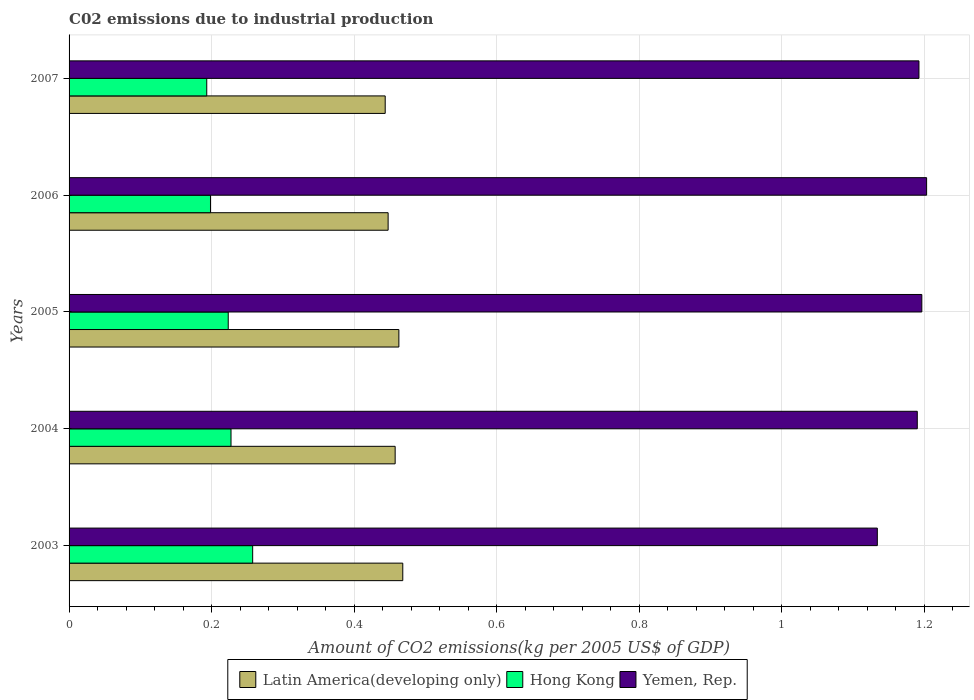How many groups of bars are there?
Provide a succinct answer. 5. Are the number of bars per tick equal to the number of legend labels?
Offer a terse response. Yes. What is the label of the 2nd group of bars from the top?
Give a very brief answer. 2006. What is the amount of CO2 emitted due to industrial production in Yemen, Rep. in 2003?
Make the answer very short. 1.13. Across all years, what is the maximum amount of CO2 emitted due to industrial production in Hong Kong?
Provide a succinct answer. 0.26. Across all years, what is the minimum amount of CO2 emitted due to industrial production in Yemen, Rep.?
Give a very brief answer. 1.13. In which year was the amount of CO2 emitted due to industrial production in Hong Kong minimum?
Provide a succinct answer. 2007. What is the total amount of CO2 emitted due to industrial production in Yemen, Rep. in the graph?
Keep it short and to the point. 5.92. What is the difference between the amount of CO2 emitted due to industrial production in Hong Kong in 2005 and that in 2006?
Provide a succinct answer. 0.02. What is the difference between the amount of CO2 emitted due to industrial production in Yemen, Rep. in 2007 and the amount of CO2 emitted due to industrial production in Latin America(developing only) in 2003?
Your answer should be compact. 0.72. What is the average amount of CO2 emitted due to industrial production in Latin America(developing only) per year?
Provide a short and direct response. 0.46. In the year 2005, what is the difference between the amount of CO2 emitted due to industrial production in Latin America(developing only) and amount of CO2 emitted due to industrial production in Yemen, Rep.?
Make the answer very short. -0.73. What is the ratio of the amount of CO2 emitted due to industrial production in Latin America(developing only) in 2004 to that in 2005?
Offer a very short reply. 0.99. Is the amount of CO2 emitted due to industrial production in Hong Kong in 2005 less than that in 2007?
Your response must be concise. No. What is the difference between the highest and the second highest amount of CO2 emitted due to industrial production in Yemen, Rep.?
Your answer should be compact. 0.01. What is the difference between the highest and the lowest amount of CO2 emitted due to industrial production in Latin America(developing only)?
Ensure brevity in your answer.  0.02. In how many years, is the amount of CO2 emitted due to industrial production in Hong Kong greater than the average amount of CO2 emitted due to industrial production in Hong Kong taken over all years?
Your response must be concise. 3. Is the sum of the amount of CO2 emitted due to industrial production in Hong Kong in 2005 and 2006 greater than the maximum amount of CO2 emitted due to industrial production in Latin America(developing only) across all years?
Offer a terse response. No. What does the 1st bar from the top in 2006 represents?
Your answer should be very brief. Yemen, Rep. What does the 1st bar from the bottom in 2003 represents?
Ensure brevity in your answer.  Latin America(developing only). Is it the case that in every year, the sum of the amount of CO2 emitted due to industrial production in Latin America(developing only) and amount of CO2 emitted due to industrial production in Yemen, Rep. is greater than the amount of CO2 emitted due to industrial production in Hong Kong?
Make the answer very short. Yes. Are all the bars in the graph horizontal?
Provide a succinct answer. Yes. What is the difference between two consecutive major ticks on the X-axis?
Offer a terse response. 0.2. Are the values on the major ticks of X-axis written in scientific E-notation?
Keep it short and to the point. No. Does the graph contain any zero values?
Ensure brevity in your answer.  No. Does the graph contain grids?
Your response must be concise. Yes. What is the title of the graph?
Keep it short and to the point. C02 emissions due to industrial production. Does "Sweden" appear as one of the legend labels in the graph?
Offer a very short reply. No. What is the label or title of the X-axis?
Offer a terse response. Amount of CO2 emissions(kg per 2005 US$ of GDP). What is the label or title of the Y-axis?
Ensure brevity in your answer.  Years. What is the Amount of CO2 emissions(kg per 2005 US$ of GDP) in Latin America(developing only) in 2003?
Give a very brief answer. 0.47. What is the Amount of CO2 emissions(kg per 2005 US$ of GDP) in Hong Kong in 2003?
Make the answer very short. 0.26. What is the Amount of CO2 emissions(kg per 2005 US$ of GDP) of Yemen, Rep. in 2003?
Provide a short and direct response. 1.13. What is the Amount of CO2 emissions(kg per 2005 US$ of GDP) in Latin America(developing only) in 2004?
Offer a terse response. 0.46. What is the Amount of CO2 emissions(kg per 2005 US$ of GDP) in Hong Kong in 2004?
Make the answer very short. 0.23. What is the Amount of CO2 emissions(kg per 2005 US$ of GDP) in Yemen, Rep. in 2004?
Provide a short and direct response. 1.19. What is the Amount of CO2 emissions(kg per 2005 US$ of GDP) of Latin America(developing only) in 2005?
Ensure brevity in your answer.  0.46. What is the Amount of CO2 emissions(kg per 2005 US$ of GDP) in Hong Kong in 2005?
Keep it short and to the point. 0.22. What is the Amount of CO2 emissions(kg per 2005 US$ of GDP) of Yemen, Rep. in 2005?
Give a very brief answer. 1.2. What is the Amount of CO2 emissions(kg per 2005 US$ of GDP) of Latin America(developing only) in 2006?
Your response must be concise. 0.45. What is the Amount of CO2 emissions(kg per 2005 US$ of GDP) of Hong Kong in 2006?
Make the answer very short. 0.2. What is the Amount of CO2 emissions(kg per 2005 US$ of GDP) of Yemen, Rep. in 2006?
Give a very brief answer. 1.2. What is the Amount of CO2 emissions(kg per 2005 US$ of GDP) of Latin America(developing only) in 2007?
Your answer should be very brief. 0.44. What is the Amount of CO2 emissions(kg per 2005 US$ of GDP) of Hong Kong in 2007?
Give a very brief answer. 0.19. What is the Amount of CO2 emissions(kg per 2005 US$ of GDP) of Yemen, Rep. in 2007?
Ensure brevity in your answer.  1.19. Across all years, what is the maximum Amount of CO2 emissions(kg per 2005 US$ of GDP) in Latin America(developing only)?
Provide a short and direct response. 0.47. Across all years, what is the maximum Amount of CO2 emissions(kg per 2005 US$ of GDP) of Hong Kong?
Provide a succinct answer. 0.26. Across all years, what is the maximum Amount of CO2 emissions(kg per 2005 US$ of GDP) in Yemen, Rep.?
Provide a succinct answer. 1.2. Across all years, what is the minimum Amount of CO2 emissions(kg per 2005 US$ of GDP) in Latin America(developing only)?
Offer a terse response. 0.44. Across all years, what is the minimum Amount of CO2 emissions(kg per 2005 US$ of GDP) in Hong Kong?
Provide a short and direct response. 0.19. Across all years, what is the minimum Amount of CO2 emissions(kg per 2005 US$ of GDP) of Yemen, Rep.?
Provide a short and direct response. 1.13. What is the total Amount of CO2 emissions(kg per 2005 US$ of GDP) of Latin America(developing only) in the graph?
Ensure brevity in your answer.  2.28. What is the total Amount of CO2 emissions(kg per 2005 US$ of GDP) in Hong Kong in the graph?
Ensure brevity in your answer.  1.1. What is the total Amount of CO2 emissions(kg per 2005 US$ of GDP) of Yemen, Rep. in the graph?
Provide a short and direct response. 5.92. What is the difference between the Amount of CO2 emissions(kg per 2005 US$ of GDP) of Latin America(developing only) in 2003 and that in 2004?
Provide a succinct answer. 0.01. What is the difference between the Amount of CO2 emissions(kg per 2005 US$ of GDP) in Hong Kong in 2003 and that in 2004?
Give a very brief answer. 0.03. What is the difference between the Amount of CO2 emissions(kg per 2005 US$ of GDP) in Yemen, Rep. in 2003 and that in 2004?
Provide a succinct answer. -0.06. What is the difference between the Amount of CO2 emissions(kg per 2005 US$ of GDP) of Latin America(developing only) in 2003 and that in 2005?
Give a very brief answer. 0.01. What is the difference between the Amount of CO2 emissions(kg per 2005 US$ of GDP) in Hong Kong in 2003 and that in 2005?
Your answer should be very brief. 0.03. What is the difference between the Amount of CO2 emissions(kg per 2005 US$ of GDP) of Yemen, Rep. in 2003 and that in 2005?
Your response must be concise. -0.06. What is the difference between the Amount of CO2 emissions(kg per 2005 US$ of GDP) of Latin America(developing only) in 2003 and that in 2006?
Give a very brief answer. 0.02. What is the difference between the Amount of CO2 emissions(kg per 2005 US$ of GDP) in Hong Kong in 2003 and that in 2006?
Offer a very short reply. 0.06. What is the difference between the Amount of CO2 emissions(kg per 2005 US$ of GDP) in Yemen, Rep. in 2003 and that in 2006?
Give a very brief answer. -0.07. What is the difference between the Amount of CO2 emissions(kg per 2005 US$ of GDP) in Latin America(developing only) in 2003 and that in 2007?
Your answer should be very brief. 0.02. What is the difference between the Amount of CO2 emissions(kg per 2005 US$ of GDP) in Hong Kong in 2003 and that in 2007?
Offer a very short reply. 0.06. What is the difference between the Amount of CO2 emissions(kg per 2005 US$ of GDP) of Yemen, Rep. in 2003 and that in 2007?
Ensure brevity in your answer.  -0.06. What is the difference between the Amount of CO2 emissions(kg per 2005 US$ of GDP) of Latin America(developing only) in 2004 and that in 2005?
Keep it short and to the point. -0.01. What is the difference between the Amount of CO2 emissions(kg per 2005 US$ of GDP) in Hong Kong in 2004 and that in 2005?
Your response must be concise. 0. What is the difference between the Amount of CO2 emissions(kg per 2005 US$ of GDP) of Yemen, Rep. in 2004 and that in 2005?
Provide a short and direct response. -0.01. What is the difference between the Amount of CO2 emissions(kg per 2005 US$ of GDP) in Latin America(developing only) in 2004 and that in 2006?
Provide a succinct answer. 0.01. What is the difference between the Amount of CO2 emissions(kg per 2005 US$ of GDP) in Hong Kong in 2004 and that in 2006?
Offer a terse response. 0.03. What is the difference between the Amount of CO2 emissions(kg per 2005 US$ of GDP) of Yemen, Rep. in 2004 and that in 2006?
Your response must be concise. -0.01. What is the difference between the Amount of CO2 emissions(kg per 2005 US$ of GDP) in Latin America(developing only) in 2004 and that in 2007?
Ensure brevity in your answer.  0.01. What is the difference between the Amount of CO2 emissions(kg per 2005 US$ of GDP) of Hong Kong in 2004 and that in 2007?
Provide a short and direct response. 0.03. What is the difference between the Amount of CO2 emissions(kg per 2005 US$ of GDP) in Yemen, Rep. in 2004 and that in 2007?
Keep it short and to the point. -0. What is the difference between the Amount of CO2 emissions(kg per 2005 US$ of GDP) of Latin America(developing only) in 2005 and that in 2006?
Ensure brevity in your answer.  0.02. What is the difference between the Amount of CO2 emissions(kg per 2005 US$ of GDP) in Hong Kong in 2005 and that in 2006?
Provide a short and direct response. 0.02. What is the difference between the Amount of CO2 emissions(kg per 2005 US$ of GDP) of Yemen, Rep. in 2005 and that in 2006?
Offer a very short reply. -0.01. What is the difference between the Amount of CO2 emissions(kg per 2005 US$ of GDP) in Latin America(developing only) in 2005 and that in 2007?
Your answer should be very brief. 0.02. What is the difference between the Amount of CO2 emissions(kg per 2005 US$ of GDP) of Hong Kong in 2005 and that in 2007?
Your response must be concise. 0.03. What is the difference between the Amount of CO2 emissions(kg per 2005 US$ of GDP) of Yemen, Rep. in 2005 and that in 2007?
Keep it short and to the point. 0. What is the difference between the Amount of CO2 emissions(kg per 2005 US$ of GDP) of Latin America(developing only) in 2006 and that in 2007?
Keep it short and to the point. 0. What is the difference between the Amount of CO2 emissions(kg per 2005 US$ of GDP) of Hong Kong in 2006 and that in 2007?
Ensure brevity in your answer.  0.01. What is the difference between the Amount of CO2 emissions(kg per 2005 US$ of GDP) of Yemen, Rep. in 2006 and that in 2007?
Make the answer very short. 0.01. What is the difference between the Amount of CO2 emissions(kg per 2005 US$ of GDP) of Latin America(developing only) in 2003 and the Amount of CO2 emissions(kg per 2005 US$ of GDP) of Hong Kong in 2004?
Provide a succinct answer. 0.24. What is the difference between the Amount of CO2 emissions(kg per 2005 US$ of GDP) in Latin America(developing only) in 2003 and the Amount of CO2 emissions(kg per 2005 US$ of GDP) in Yemen, Rep. in 2004?
Your response must be concise. -0.72. What is the difference between the Amount of CO2 emissions(kg per 2005 US$ of GDP) in Hong Kong in 2003 and the Amount of CO2 emissions(kg per 2005 US$ of GDP) in Yemen, Rep. in 2004?
Offer a very short reply. -0.93. What is the difference between the Amount of CO2 emissions(kg per 2005 US$ of GDP) of Latin America(developing only) in 2003 and the Amount of CO2 emissions(kg per 2005 US$ of GDP) of Hong Kong in 2005?
Your response must be concise. 0.24. What is the difference between the Amount of CO2 emissions(kg per 2005 US$ of GDP) in Latin America(developing only) in 2003 and the Amount of CO2 emissions(kg per 2005 US$ of GDP) in Yemen, Rep. in 2005?
Keep it short and to the point. -0.73. What is the difference between the Amount of CO2 emissions(kg per 2005 US$ of GDP) of Hong Kong in 2003 and the Amount of CO2 emissions(kg per 2005 US$ of GDP) of Yemen, Rep. in 2005?
Ensure brevity in your answer.  -0.94. What is the difference between the Amount of CO2 emissions(kg per 2005 US$ of GDP) in Latin America(developing only) in 2003 and the Amount of CO2 emissions(kg per 2005 US$ of GDP) in Hong Kong in 2006?
Ensure brevity in your answer.  0.27. What is the difference between the Amount of CO2 emissions(kg per 2005 US$ of GDP) in Latin America(developing only) in 2003 and the Amount of CO2 emissions(kg per 2005 US$ of GDP) in Yemen, Rep. in 2006?
Your answer should be compact. -0.73. What is the difference between the Amount of CO2 emissions(kg per 2005 US$ of GDP) of Hong Kong in 2003 and the Amount of CO2 emissions(kg per 2005 US$ of GDP) of Yemen, Rep. in 2006?
Ensure brevity in your answer.  -0.95. What is the difference between the Amount of CO2 emissions(kg per 2005 US$ of GDP) of Latin America(developing only) in 2003 and the Amount of CO2 emissions(kg per 2005 US$ of GDP) of Hong Kong in 2007?
Your answer should be compact. 0.28. What is the difference between the Amount of CO2 emissions(kg per 2005 US$ of GDP) of Latin America(developing only) in 2003 and the Amount of CO2 emissions(kg per 2005 US$ of GDP) of Yemen, Rep. in 2007?
Keep it short and to the point. -0.72. What is the difference between the Amount of CO2 emissions(kg per 2005 US$ of GDP) of Hong Kong in 2003 and the Amount of CO2 emissions(kg per 2005 US$ of GDP) of Yemen, Rep. in 2007?
Your response must be concise. -0.93. What is the difference between the Amount of CO2 emissions(kg per 2005 US$ of GDP) in Latin America(developing only) in 2004 and the Amount of CO2 emissions(kg per 2005 US$ of GDP) in Hong Kong in 2005?
Give a very brief answer. 0.23. What is the difference between the Amount of CO2 emissions(kg per 2005 US$ of GDP) in Latin America(developing only) in 2004 and the Amount of CO2 emissions(kg per 2005 US$ of GDP) in Yemen, Rep. in 2005?
Make the answer very short. -0.74. What is the difference between the Amount of CO2 emissions(kg per 2005 US$ of GDP) of Hong Kong in 2004 and the Amount of CO2 emissions(kg per 2005 US$ of GDP) of Yemen, Rep. in 2005?
Offer a terse response. -0.97. What is the difference between the Amount of CO2 emissions(kg per 2005 US$ of GDP) in Latin America(developing only) in 2004 and the Amount of CO2 emissions(kg per 2005 US$ of GDP) in Hong Kong in 2006?
Ensure brevity in your answer.  0.26. What is the difference between the Amount of CO2 emissions(kg per 2005 US$ of GDP) of Latin America(developing only) in 2004 and the Amount of CO2 emissions(kg per 2005 US$ of GDP) of Yemen, Rep. in 2006?
Keep it short and to the point. -0.75. What is the difference between the Amount of CO2 emissions(kg per 2005 US$ of GDP) of Hong Kong in 2004 and the Amount of CO2 emissions(kg per 2005 US$ of GDP) of Yemen, Rep. in 2006?
Make the answer very short. -0.98. What is the difference between the Amount of CO2 emissions(kg per 2005 US$ of GDP) in Latin America(developing only) in 2004 and the Amount of CO2 emissions(kg per 2005 US$ of GDP) in Hong Kong in 2007?
Make the answer very short. 0.26. What is the difference between the Amount of CO2 emissions(kg per 2005 US$ of GDP) of Latin America(developing only) in 2004 and the Amount of CO2 emissions(kg per 2005 US$ of GDP) of Yemen, Rep. in 2007?
Provide a succinct answer. -0.73. What is the difference between the Amount of CO2 emissions(kg per 2005 US$ of GDP) in Hong Kong in 2004 and the Amount of CO2 emissions(kg per 2005 US$ of GDP) in Yemen, Rep. in 2007?
Make the answer very short. -0.97. What is the difference between the Amount of CO2 emissions(kg per 2005 US$ of GDP) in Latin America(developing only) in 2005 and the Amount of CO2 emissions(kg per 2005 US$ of GDP) in Hong Kong in 2006?
Give a very brief answer. 0.26. What is the difference between the Amount of CO2 emissions(kg per 2005 US$ of GDP) of Latin America(developing only) in 2005 and the Amount of CO2 emissions(kg per 2005 US$ of GDP) of Yemen, Rep. in 2006?
Your answer should be very brief. -0.74. What is the difference between the Amount of CO2 emissions(kg per 2005 US$ of GDP) of Hong Kong in 2005 and the Amount of CO2 emissions(kg per 2005 US$ of GDP) of Yemen, Rep. in 2006?
Your answer should be very brief. -0.98. What is the difference between the Amount of CO2 emissions(kg per 2005 US$ of GDP) of Latin America(developing only) in 2005 and the Amount of CO2 emissions(kg per 2005 US$ of GDP) of Hong Kong in 2007?
Make the answer very short. 0.27. What is the difference between the Amount of CO2 emissions(kg per 2005 US$ of GDP) of Latin America(developing only) in 2005 and the Amount of CO2 emissions(kg per 2005 US$ of GDP) of Yemen, Rep. in 2007?
Keep it short and to the point. -0.73. What is the difference between the Amount of CO2 emissions(kg per 2005 US$ of GDP) in Hong Kong in 2005 and the Amount of CO2 emissions(kg per 2005 US$ of GDP) in Yemen, Rep. in 2007?
Provide a short and direct response. -0.97. What is the difference between the Amount of CO2 emissions(kg per 2005 US$ of GDP) of Latin America(developing only) in 2006 and the Amount of CO2 emissions(kg per 2005 US$ of GDP) of Hong Kong in 2007?
Give a very brief answer. 0.25. What is the difference between the Amount of CO2 emissions(kg per 2005 US$ of GDP) in Latin America(developing only) in 2006 and the Amount of CO2 emissions(kg per 2005 US$ of GDP) in Yemen, Rep. in 2007?
Ensure brevity in your answer.  -0.74. What is the difference between the Amount of CO2 emissions(kg per 2005 US$ of GDP) of Hong Kong in 2006 and the Amount of CO2 emissions(kg per 2005 US$ of GDP) of Yemen, Rep. in 2007?
Your answer should be very brief. -0.99. What is the average Amount of CO2 emissions(kg per 2005 US$ of GDP) of Latin America(developing only) per year?
Your response must be concise. 0.46. What is the average Amount of CO2 emissions(kg per 2005 US$ of GDP) of Hong Kong per year?
Provide a short and direct response. 0.22. What is the average Amount of CO2 emissions(kg per 2005 US$ of GDP) in Yemen, Rep. per year?
Offer a terse response. 1.18. In the year 2003, what is the difference between the Amount of CO2 emissions(kg per 2005 US$ of GDP) of Latin America(developing only) and Amount of CO2 emissions(kg per 2005 US$ of GDP) of Hong Kong?
Offer a very short reply. 0.21. In the year 2003, what is the difference between the Amount of CO2 emissions(kg per 2005 US$ of GDP) of Latin America(developing only) and Amount of CO2 emissions(kg per 2005 US$ of GDP) of Yemen, Rep.?
Give a very brief answer. -0.67. In the year 2003, what is the difference between the Amount of CO2 emissions(kg per 2005 US$ of GDP) of Hong Kong and Amount of CO2 emissions(kg per 2005 US$ of GDP) of Yemen, Rep.?
Your response must be concise. -0.88. In the year 2004, what is the difference between the Amount of CO2 emissions(kg per 2005 US$ of GDP) of Latin America(developing only) and Amount of CO2 emissions(kg per 2005 US$ of GDP) of Hong Kong?
Give a very brief answer. 0.23. In the year 2004, what is the difference between the Amount of CO2 emissions(kg per 2005 US$ of GDP) of Latin America(developing only) and Amount of CO2 emissions(kg per 2005 US$ of GDP) of Yemen, Rep.?
Your response must be concise. -0.73. In the year 2004, what is the difference between the Amount of CO2 emissions(kg per 2005 US$ of GDP) of Hong Kong and Amount of CO2 emissions(kg per 2005 US$ of GDP) of Yemen, Rep.?
Provide a succinct answer. -0.96. In the year 2005, what is the difference between the Amount of CO2 emissions(kg per 2005 US$ of GDP) of Latin America(developing only) and Amount of CO2 emissions(kg per 2005 US$ of GDP) of Hong Kong?
Give a very brief answer. 0.24. In the year 2005, what is the difference between the Amount of CO2 emissions(kg per 2005 US$ of GDP) in Latin America(developing only) and Amount of CO2 emissions(kg per 2005 US$ of GDP) in Yemen, Rep.?
Keep it short and to the point. -0.73. In the year 2005, what is the difference between the Amount of CO2 emissions(kg per 2005 US$ of GDP) in Hong Kong and Amount of CO2 emissions(kg per 2005 US$ of GDP) in Yemen, Rep.?
Ensure brevity in your answer.  -0.97. In the year 2006, what is the difference between the Amount of CO2 emissions(kg per 2005 US$ of GDP) of Latin America(developing only) and Amount of CO2 emissions(kg per 2005 US$ of GDP) of Hong Kong?
Offer a terse response. 0.25. In the year 2006, what is the difference between the Amount of CO2 emissions(kg per 2005 US$ of GDP) in Latin America(developing only) and Amount of CO2 emissions(kg per 2005 US$ of GDP) in Yemen, Rep.?
Keep it short and to the point. -0.76. In the year 2006, what is the difference between the Amount of CO2 emissions(kg per 2005 US$ of GDP) in Hong Kong and Amount of CO2 emissions(kg per 2005 US$ of GDP) in Yemen, Rep.?
Provide a succinct answer. -1. In the year 2007, what is the difference between the Amount of CO2 emissions(kg per 2005 US$ of GDP) of Latin America(developing only) and Amount of CO2 emissions(kg per 2005 US$ of GDP) of Hong Kong?
Your response must be concise. 0.25. In the year 2007, what is the difference between the Amount of CO2 emissions(kg per 2005 US$ of GDP) of Latin America(developing only) and Amount of CO2 emissions(kg per 2005 US$ of GDP) of Yemen, Rep.?
Keep it short and to the point. -0.75. In the year 2007, what is the difference between the Amount of CO2 emissions(kg per 2005 US$ of GDP) of Hong Kong and Amount of CO2 emissions(kg per 2005 US$ of GDP) of Yemen, Rep.?
Your answer should be very brief. -1. What is the ratio of the Amount of CO2 emissions(kg per 2005 US$ of GDP) in Latin America(developing only) in 2003 to that in 2004?
Your answer should be very brief. 1.02. What is the ratio of the Amount of CO2 emissions(kg per 2005 US$ of GDP) in Hong Kong in 2003 to that in 2004?
Provide a short and direct response. 1.13. What is the ratio of the Amount of CO2 emissions(kg per 2005 US$ of GDP) of Yemen, Rep. in 2003 to that in 2004?
Your answer should be very brief. 0.95. What is the ratio of the Amount of CO2 emissions(kg per 2005 US$ of GDP) in Latin America(developing only) in 2003 to that in 2005?
Make the answer very short. 1.01. What is the ratio of the Amount of CO2 emissions(kg per 2005 US$ of GDP) in Hong Kong in 2003 to that in 2005?
Give a very brief answer. 1.15. What is the ratio of the Amount of CO2 emissions(kg per 2005 US$ of GDP) of Yemen, Rep. in 2003 to that in 2005?
Your response must be concise. 0.95. What is the ratio of the Amount of CO2 emissions(kg per 2005 US$ of GDP) in Latin America(developing only) in 2003 to that in 2006?
Offer a terse response. 1.05. What is the ratio of the Amount of CO2 emissions(kg per 2005 US$ of GDP) of Hong Kong in 2003 to that in 2006?
Your answer should be very brief. 1.3. What is the ratio of the Amount of CO2 emissions(kg per 2005 US$ of GDP) of Yemen, Rep. in 2003 to that in 2006?
Keep it short and to the point. 0.94. What is the ratio of the Amount of CO2 emissions(kg per 2005 US$ of GDP) in Latin America(developing only) in 2003 to that in 2007?
Make the answer very short. 1.06. What is the ratio of the Amount of CO2 emissions(kg per 2005 US$ of GDP) of Hong Kong in 2003 to that in 2007?
Your response must be concise. 1.33. What is the ratio of the Amount of CO2 emissions(kg per 2005 US$ of GDP) in Yemen, Rep. in 2003 to that in 2007?
Give a very brief answer. 0.95. What is the ratio of the Amount of CO2 emissions(kg per 2005 US$ of GDP) in Latin America(developing only) in 2004 to that in 2005?
Provide a succinct answer. 0.99. What is the ratio of the Amount of CO2 emissions(kg per 2005 US$ of GDP) of Hong Kong in 2004 to that in 2005?
Your response must be concise. 1.02. What is the ratio of the Amount of CO2 emissions(kg per 2005 US$ of GDP) of Yemen, Rep. in 2004 to that in 2005?
Keep it short and to the point. 0.99. What is the ratio of the Amount of CO2 emissions(kg per 2005 US$ of GDP) in Latin America(developing only) in 2004 to that in 2006?
Keep it short and to the point. 1.02. What is the ratio of the Amount of CO2 emissions(kg per 2005 US$ of GDP) of Hong Kong in 2004 to that in 2006?
Provide a succinct answer. 1.15. What is the ratio of the Amount of CO2 emissions(kg per 2005 US$ of GDP) of Latin America(developing only) in 2004 to that in 2007?
Keep it short and to the point. 1.03. What is the ratio of the Amount of CO2 emissions(kg per 2005 US$ of GDP) in Hong Kong in 2004 to that in 2007?
Ensure brevity in your answer.  1.18. What is the ratio of the Amount of CO2 emissions(kg per 2005 US$ of GDP) of Yemen, Rep. in 2004 to that in 2007?
Provide a succinct answer. 1. What is the ratio of the Amount of CO2 emissions(kg per 2005 US$ of GDP) of Latin America(developing only) in 2005 to that in 2006?
Provide a short and direct response. 1.03. What is the ratio of the Amount of CO2 emissions(kg per 2005 US$ of GDP) of Hong Kong in 2005 to that in 2006?
Keep it short and to the point. 1.13. What is the ratio of the Amount of CO2 emissions(kg per 2005 US$ of GDP) of Yemen, Rep. in 2005 to that in 2006?
Your answer should be very brief. 0.99. What is the ratio of the Amount of CO2 emissions(kg per 2005 US$ of GDP) of Latin America(developing only) in 2005 to that in 2007?
Offer a terse response. 1.04. What is the ratio of the Amount of CO2 emissions(kg per 2005 US$ of GDP) in Hong Kong in 2005 to that in 2007?
Offer a terse response. 1.16. What is the ratio of the Amount of CO2 emissions(kg per 2005 US$ of GDP) in Yemen, Rep. in 2005 to that in 2007?
Provide a short and direct response. 1. What is the ratio of the Amount of CO2 emissions(kg per 2005 US$ of GDP) in Latin America(developing only) in 2006 to that in 2007?
Your answer should be compact. 1.01. What is the ratio of the Amount of CO2 emissions(kg per 2005 US$ of GDP) in Hong Kong in 2006 to that in 2007?
Give a very brief answer. 1.03. What is the ratio of the Amount of CO2 emissions(kg per 2005 US$ of GDP) of Yemen, Rep. in 2006 to that in 2007?
Offer a very short reply. 1.01. What is the difference between the highest and the second highest Amount of CO2 emissions(kg per 2005 US$ of GDP) of Latin America(developing only)?
Make the answer very short. 0.01. What is the difference between the highest and the second highest Amount of CO2 emissions(kg per 2005 US$ of GDP) in Hong Kong?
Make the answer very short. 0.03. What is the difference between the highest and the second highest Amount of CO2 emissions(kg per 2005 US$ of GDP) in Yemen, Rep.?
Your answer should be compact. 0.01. What is the difference between the highest and the lowest Amount of CO2 emissions(kg per 2005 US$ of GDP) in Latin America(developing only)?
Provide a succinct answer. 0.02. What is the difference between the highest and the lowest Amount of CO2 emissions(kg per 2005 US$ of GDP) in Hong Kong?
Keep it short and to the point. 0.06. What is the difference between the highest and the lowest Amount of CO2 emissions(kg per 2005 US$ of GDP) of Yemen, Rep.?
Make the answer very short. 0.07. 